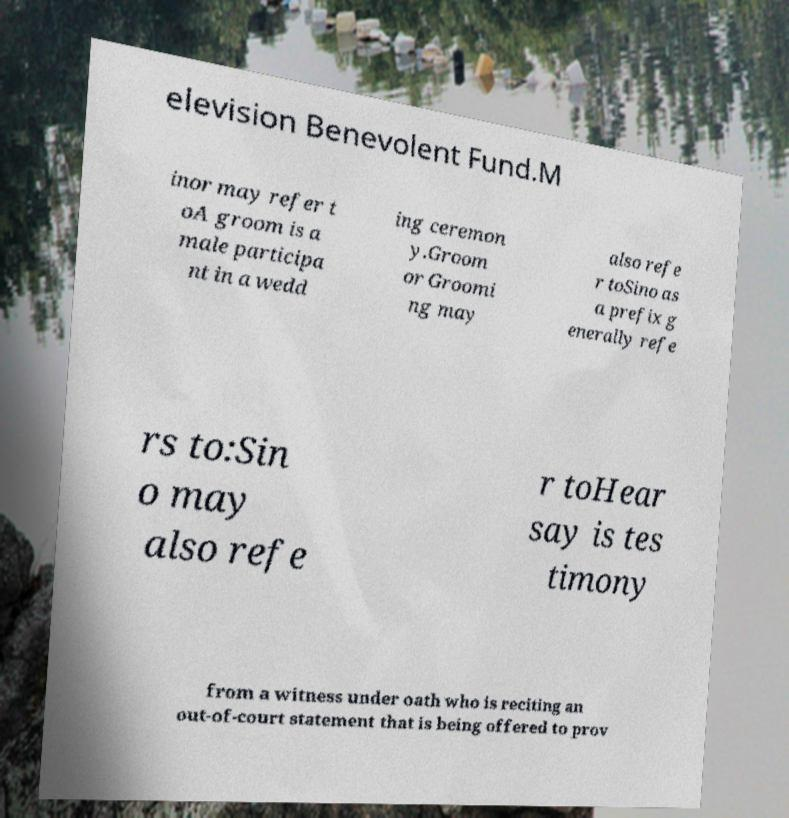Can you accurately transcribe the text from the provided image for me? elevision Benevolent Fund.M inor may refer t oA groom is a male participa nt in a wedd ing ceremon y.Groom or Groomi ng may also refe r toSino as a prefix g enerally refe rs to:Sin o may also refe r toHear say is tes timony from a witness under oath who is reciting an out-of-court statement that is being offered to prov 